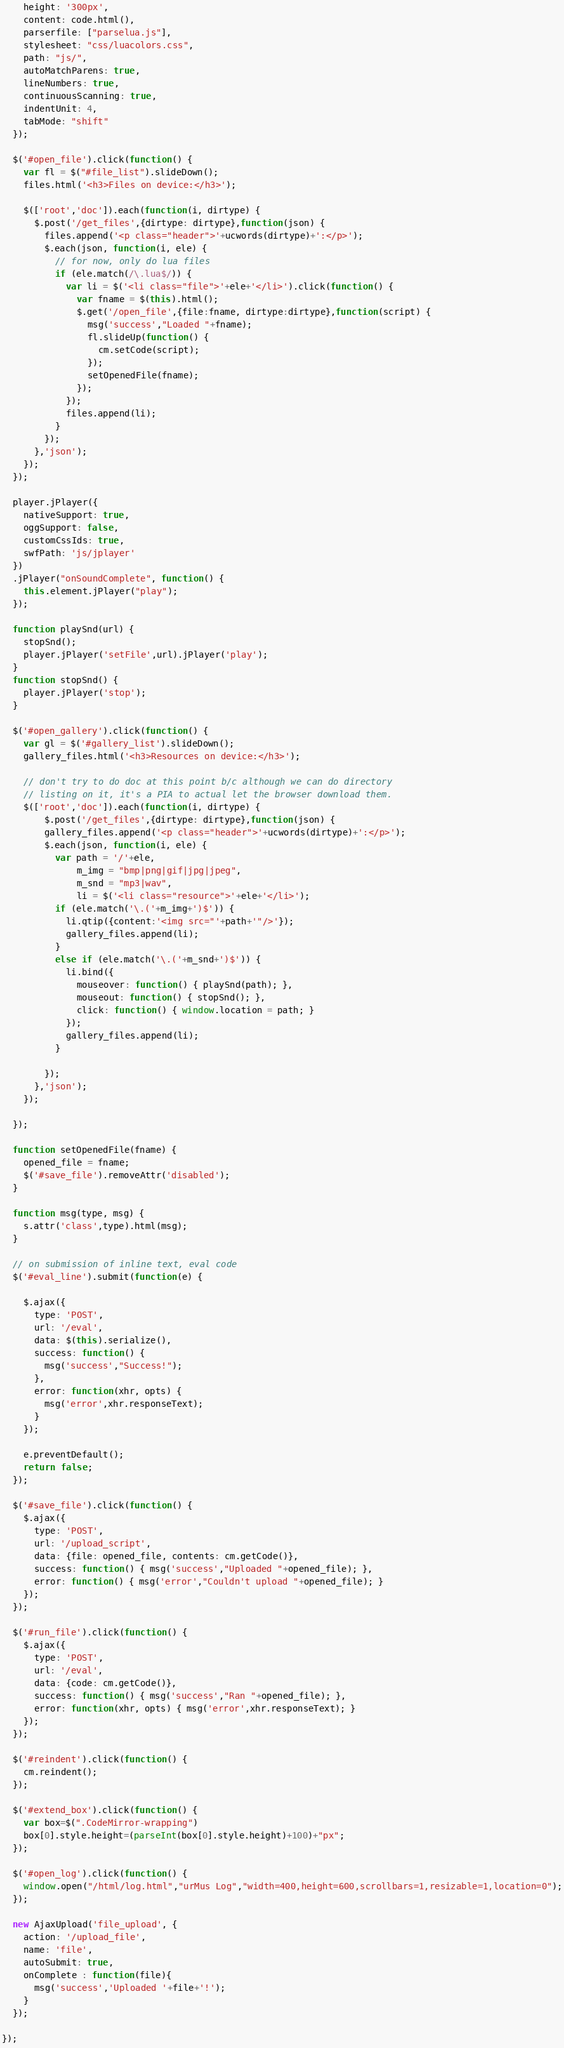<code> <loc_0><loc_0><loc_500><loc_500><_JavaScript_>    height: '300px',
    content: code.html(),
    parserfile: ["parselua.js"],
    stylesheet: "css/luacolors.css",
    path: "js/",
    autoMatchParens: true,
    lineNumbers: true,
    continuousScanning: true,
    indentUnit: 4,
    tabMode: "shift"
  });
  
  $('#open_file').click(function() {
    var fl = $("#file_list").slideDown();
    files.html('<h3>Files on device:</h3>');
    
    $(['root','doc']).each(function(i, dirtype) {
      $.post('/get_files',{dirtype: dirtype},function(json) {
        files.append('<p class="header">'+ucwords(dirtype)+':</p>');
        $.each(json, function(i, ele) {
          // for now, only do lua files
          if (ele.match(/\.lua$/)) {
            var li = $('<li class="file">'+ele+'</li>').click(function() {
              var fname = $(this).html();
              $.get('/open_file',{file:fname, dirtype:dirtype},function(script) {
                msg('success',"Loaded "+fname);
                fl.slideUp(function() {
                  cm.setCode(script);                
                });
                setOpenedFile(fname);
              });
            });
            files.append(li);
          }
        });
      },'json');          
    });
  });

  player.jPlayer({
    nativeSupport: true, 
    oggSupport: false, 
    customCssIds: true,
    swfPath: 'js/jplayer'
  })
  .jPlayer("onSoundComplete", function() {
    this.element.jPlayer("play");
  });
  
  function playSnd(url) {
    stopSnd();
    player.jPlayer('setFile',url).jPlayer('play');
  }
  function stopSnd() {
    player.jPlayer('stop');
  }
  
  $('#open_gallery').click(function() {
    var gl = $('#gallery_list').slideDown();
    gallery_files.html('<h3>Resources on device:</h3>');

    // don't try to do doc at this point b/c although we can do directory
    // listing on it, it's a PIA to actual let the browser download them.
    $(['root','doc']).each(function(i, dirtype) {
		$.post('/get_files',{dirtype: dirtype},function(json) {
        gallery_files.append('<p class="header">'+ucwords(dirtype)+':</p>');
        $.each(json, function(i, ele) {
          var path = '/'+ele, 
              m_img = "bmp|png|gif|jpg|jpeg",
              m_snd = "mp3|wav",
              li = $('<li class="resource">'+ele+'</li>');
          if (ele.match('\.('+m_img+')$')) {
            li.qtip({content:'<img src="'+path+'"/>'});
            gallery_files.append(li);
          }
          else if (ele.match('\.('+m_snd+')$')) {
            li.bind({
              mouseover: function() { playSnd(path); },
              mouseout: function() { stopSnd(); },
              click: function() { window.location = path; }
            });
            gallery_files.append(li);
          }
          
        });
      },'json');          
    });
    
  });
  
  function setOpenedFile(fname) {
    opened_file = fname;
    $('#save_file').removeAttr('disabled');
  }

  function msg(type, msg) {
    s.attr('class',type).html(msg);
  }

  // on submission of inline text, eval code 
  $('#eval_line').submit(function(e) {

    $.ajax({
      type: 'POST',
      url: '/eval',
      data: $(this).serialize(),
      success: function() {
        msg('success',"Success!");
      },
      error: function(xhr, opts) {
        msg('error',xhr.responseText);
      }
    });

    e.preventDefault();
    return false;
  });
  
  $('#save_file').click(function() {
    $.ajax({
      type: 'POST',
      url: '/upload_script',
      data: {file: opened_file, contents: cm.getCode()},
      success: function() { msg('success',"Uploaded "+opened_file); },
      error: function() { msg('error',"Couldn't upload "+opened_file); }
    });
  });
  
  $('#run_file').click(function() {
    $.ajax({
      type: 'POST',
      url: '/eval',
      data: {code: cm.getCode()},
      success: function() { msg('success',"Ran "+opened_file); },
      error: function(xhr, opts) { msg('error',xhr.responseText); }
    });
  });
  
  $('#reindent').click(function() {
    cm.reindent();
  });
  
  $('#extend_box').click(function() {
    var box=$(".CodeMirror-wrapping")
    box[0].style.height=(parseInt(box[0].style.height)+100)+"px";
  });
				  
  $('#open_log').click(function() {
    window.open("/html/log.html","urMus Log","width=400,height=600,scrollbars=1,resizable=1,location=0");
  });
          
  new AjaxUpload('file_upload', {
    action: '/upload_file',
    name: 'file',
    autoSubmit: true,
    onComplete : function(file){
      msg('success','Uploaded '+file+'!');
    } 
  });

});</code> 